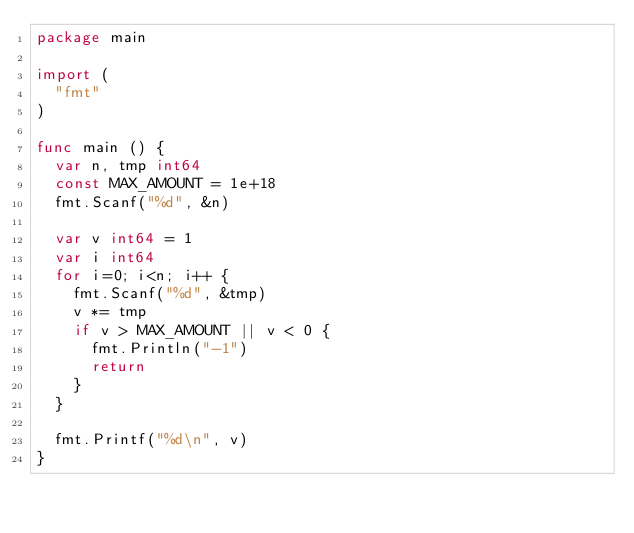<code> <loc_0><loc_0><loc_500><loc_500><_Go_>package main

import (
  "fmt"
)

func main () {
  var n, tmp int64
  const MAX_AMOUNT = 1e+18
  fmt.Scanf("%d", &n)

  var v int64 = 1
  var i int64
  for i=0; i<n; i++ {
    fmt.Scanf("%d", &tmp)
    v *= tmp
    if v > MAX_AMOUNT || v < 0 {
      fmt.Println("-1")
      return
    }
  }

  fmt.Printf("%d\n", v)
}</code> 